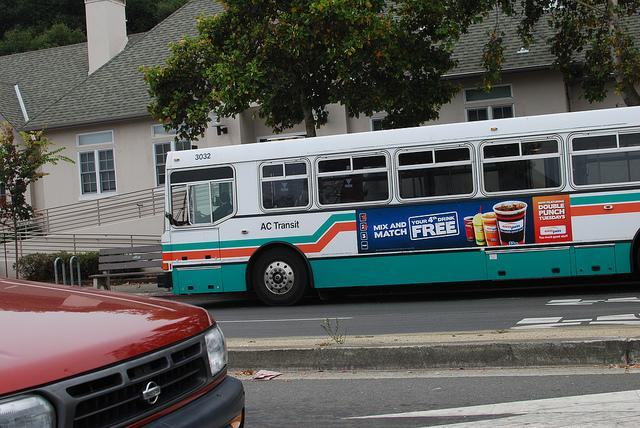What day is Double Punch?

Choices:
A) wednesday
B) friday
C) monday
D) tuesday tuesday 